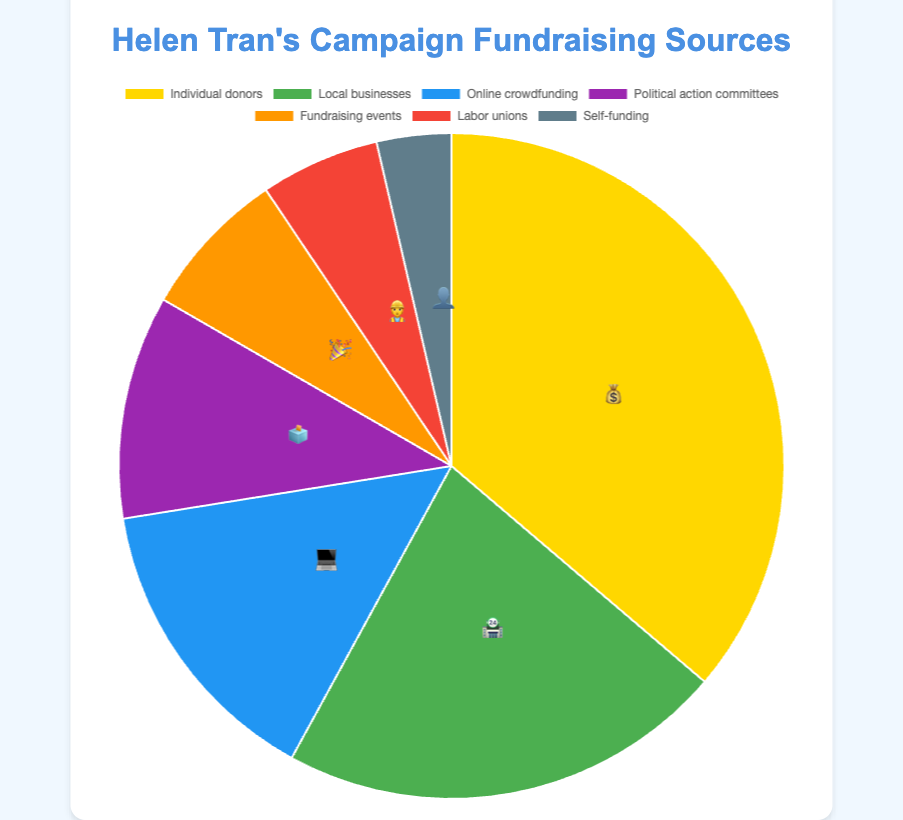Which fundraising source contributed the most? The chart shows the amounts raised from different sources. Individual donors contributed $250,000, which is the highest amount among all sources.
Answer: Individual donors Which fundraising source is represented by the 🎉 emoji? The chart includes emojis as labels for each fundraising source. The 🎉 emoji corresponds to fundraising events, which raised $50,000.
Answer: Fundraising events What is the total amount raised from Political action committees and Labor unions? The chart shows that Political action committees raised $75,000 and Labor unions raised $40,000. Summing these amounts gives $75,000 + $40,000 = $115,000.
Answer: $115,000 Which source contributed the least amount to Helen Tran’s campaign? The chart displays various sources with their contributions. Self-funding is the source with the lowest contribution, amounting to $25,000.
Answer: Self-funding How does the amount raised from Local businesses compare to Online crowdfunding? Local businesses raised $150,000 while Online crowdfunding raised $100,000. Therefore, Local businesses raised $50,000 more than Online crowdfunding.
Answer: $50,000 more What is the combined contribution of Individual donors and Local businesses? Adding the contributions from Individual donors ($250,000) and Local businesses ($150,000) results in $250,000 + $150,000 = $400,000.
Answer: $400,000 If you combine the contributions from Fundraising events and Self-funding, is the total greater than that of Political action committees? The contribution from Fundraising events is $50,000 and Self-funding is $25,000. Their combined total is $50,000 + $25,000 = $75,000, which equals the contribution from Political action committees, hence not greater.
Answer: No, it's equal Which sources raised more than $75,000? The chart displays amounts raised by various sources. Individual donors, Local businesses, and Online crowdfunding raised more than $75,000 with totals of $250,000, $150,000, and $100,000 respectively.
Answer: Individual donors, Local businesses, Online crowdfunding 